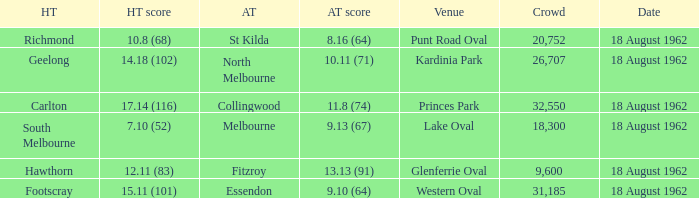What was the home team that scored 10.8 (68)? Richmond. 